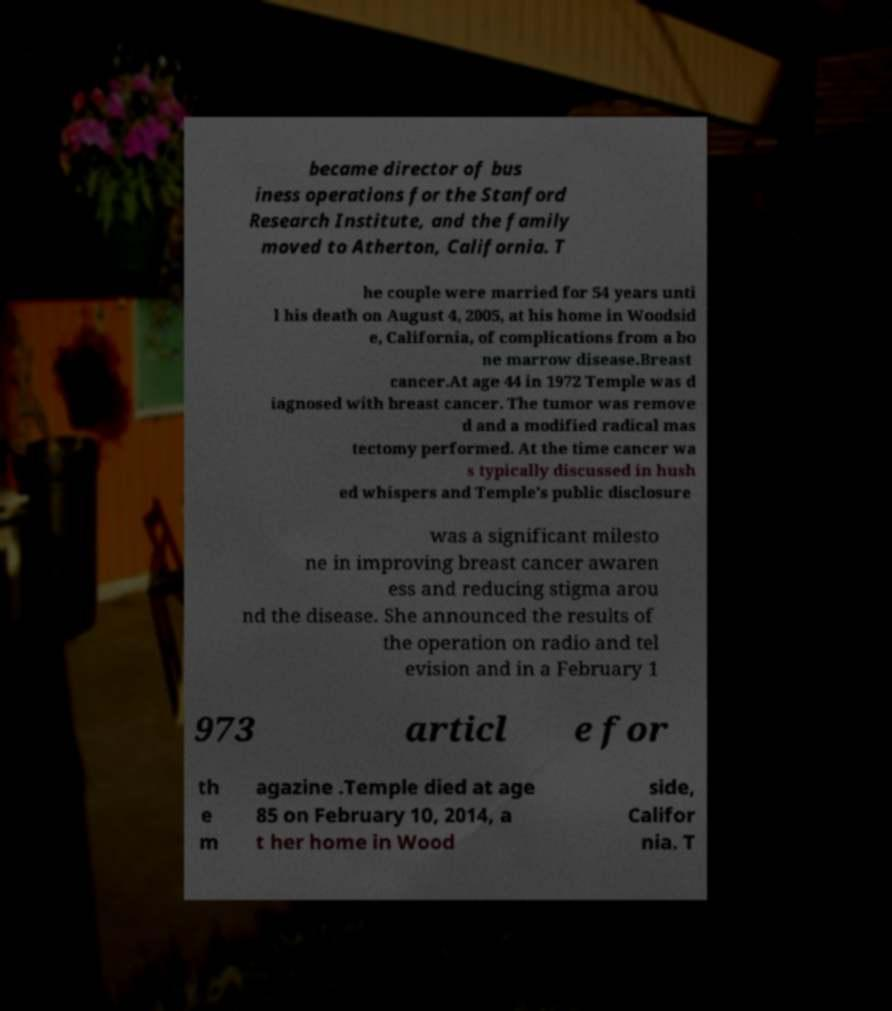There's text embedded in this image that I need extracted. Can you transcribe it verbatim? became director of bus iness operations for the Stanford Research Institute, and the family moved to Atherton, California. T he couple were married for 54 years unti l his death on August 4, 2005, at his home in Woodsid e, California, of complications from a bo ne marrow disease.Breast cancer.At age 44 in 1972 Temple was d iagnosed with breast cancer. The tumor was remove d and a modified radical mas tectomy performed. At the time cancer wa s typically discussed in hush ed whispers and Temple's public disclosure was a significant milesto ne in improving breast cancer awaren ess and reducing stigma arou nd the disease. She announced the results of the operation on radio and tel evision and in a February 1 973 articl e for th e m agazine .Temple died at age 85 on February 10, 2014, a t her home in Wood side, Califor nia. T 